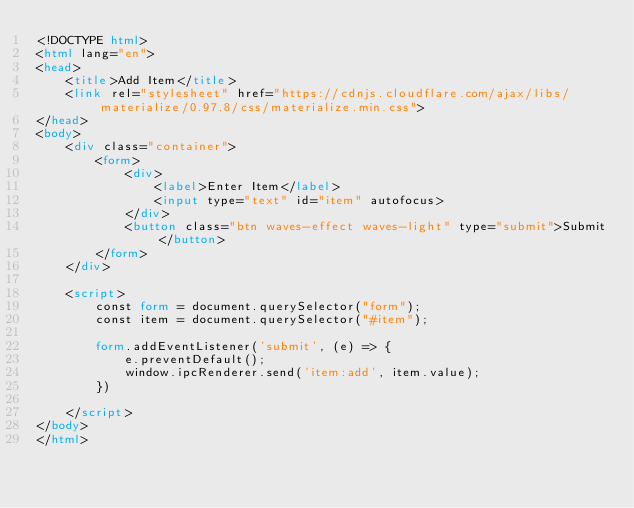Convert code to text. <code><loc_0><loc_0><loc_500><loc_500><_HTML_><!DOCTYPE html>
<html lang="en">
<head>
    <title>Add Item</title>
    <link rel="stylesheet" href="https://cdnjs.cloudflare.com/ajax/libs/materialize/0.97.8/css/materialize.min.css">
</head>
<body>
    <div class="container">
        <form>
            <div>
                <label>Enter Item</label>
                <input type="text" id="item" autofocus>
            </div>
            <button class="btn waves-effect waves-light" type="submit">Submit</button>
        </form>
    </div>
    
    <script>
        const form = document.querySelector("form");
        const item = document.querySelector("#item");
        
        form.addEventListener('submit', (e) => {
            e.preventDefault();
            window.ipcRenderer.send('item:add', item.value);
        })

    </script>
</body>
</html></code> 